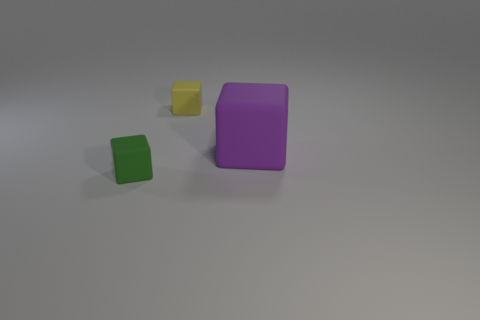Are there any yellow blocks in front of the yellow matte cube?
Offer a very short reply. No. What is the shape of the green rubber thing?
Provide a succinct answer. Cube. What number of things are small rubber blocks to the left of the yellow rubber cube or yellow cubes?
Offer a very short reply. 2. What number of other things are the same color as the big object?
Keep it short and to the point. 0. Do the big object and the small rubber block in front of the big purple matte thing have the same color?
Give a very brief answer. No. The other small matte thing that is the same shape as the small green rubber object is what color?
Offer a very short reply. Yellow. Does the big object have the same material as the cube to the left of the yellow cube?
Your answer should be very brief. Yes. The large cube has what color?
Provide a short and direct response. Purple. There is a matte thing right of the small cube behind the small cube that is in front of the yellow rubber thing; what color is it?
Give a very brief answer. Purple. There is a yellow rubber thing; is it the same shape as the matte thing in front of the large purple rubber thing?
Give a very brief answer. Yes. 